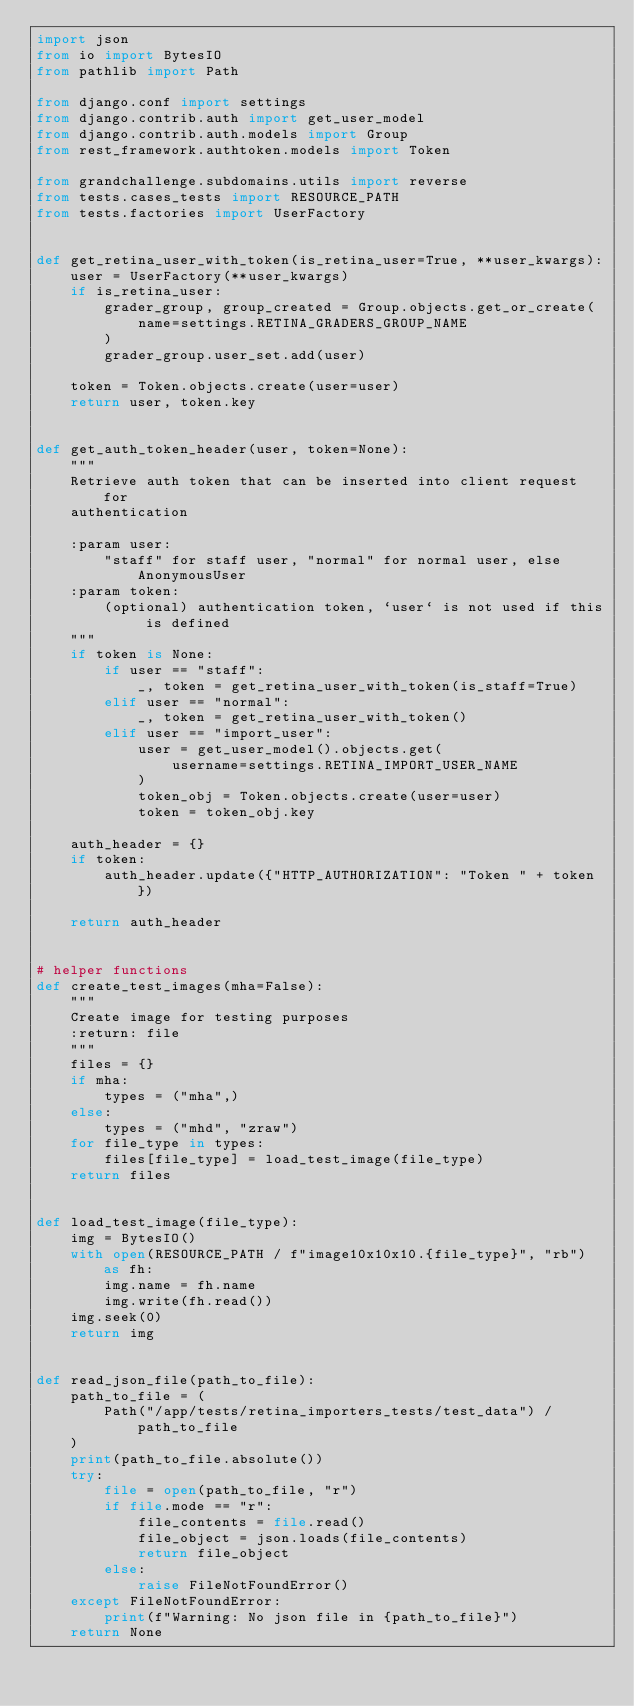Convert code to text. <code><loc_0><loc_0><loc_500><loc_500><_Python_>import json
from io import BytesIO
from pathlib import Path

from django.conf import settings
from django.contrib.auth import get_user_model
from django.contrib.auth.models import Group
from rest_framework.authtoken.models import Token

from grandchallenge.subdomains.utils import reverse
from tests.cases_tests import RESOURCE_PATH
from tests.factories import UserFactory


def get_retina_user_with_token(is_retina_user=True, **user_kwargs):
    user = UserFactory(**user_kwargs)
    if is_retina_user:
        grader_group, group_created = Group.objects.get_or_create(
            name=settings.RETINA_GRADERS_GROUP_NAME
        )
        grader_group.user_set.add(user)

    token = Token.objects.create(user=user)
    return user, token.key


def get_auth_token_header(user, token=None):
    """
    Retrieve auth token that can be inserted into client request for
    authentication

    :param user:
        "staff" for staff user, "normal" for normal user, else AnonymousUser
    :param token:
        (optional) authentication token, `user` is not used if this is defined
    """
    if token is None:
        if user == "staff":
            _, token = get_retina_user_with_token(is_staff=True)
        elif user == "normal":
            _, token = get_retina_user_with_token()
        elif user == "import_user":
            user = get_user_model().objects.get(
                username=settings.RETINA_IMPORT_USER_NAME
            )
            token_obj = Token.objects.create(user=user)
            token = token_obj.key

    auth_header = {}
    if token:
        auth_header.update({"HTTP_AUTHORIZATION": "Token " + token})

    return auth_header


# helper functions
def create_test_images(mha=False):
    """
    Create image for testing purposes
    :return: file
    """
    files = {}
    if mha:
        types = ("mha",)
    else:
        types = ("mhd", "zraw")
    for file_type in types:
        files[file_type] = load_test_image(file_type)
    return files


def load_test_image(file_type):
    img = BytesIO()
    with open(RESOURCE_PATH / f"image10x10x10.{file_type}", "rb") as fh:
        img.name = fh.name
        img.write(fh.read())
    img.seek(0)
    return img


def read_json_file(path_to_file):
    path_to_file = (
        Path("/app/tests/retina_importers_tests/test_data") / path_to_file
    )
    print(path_to_file.absolute())
    try:
        file = open(path_to_file, "r")
        if file.mode == "r":
            file_contents = file.read()
            file_object = json.loads(file_contents)
            return file_object
        else:
            raise FileNotFoundError()
    except FileNotFoundError:
        print(f"Warning: No json file in {path_to_file}")
    return None

</code> 